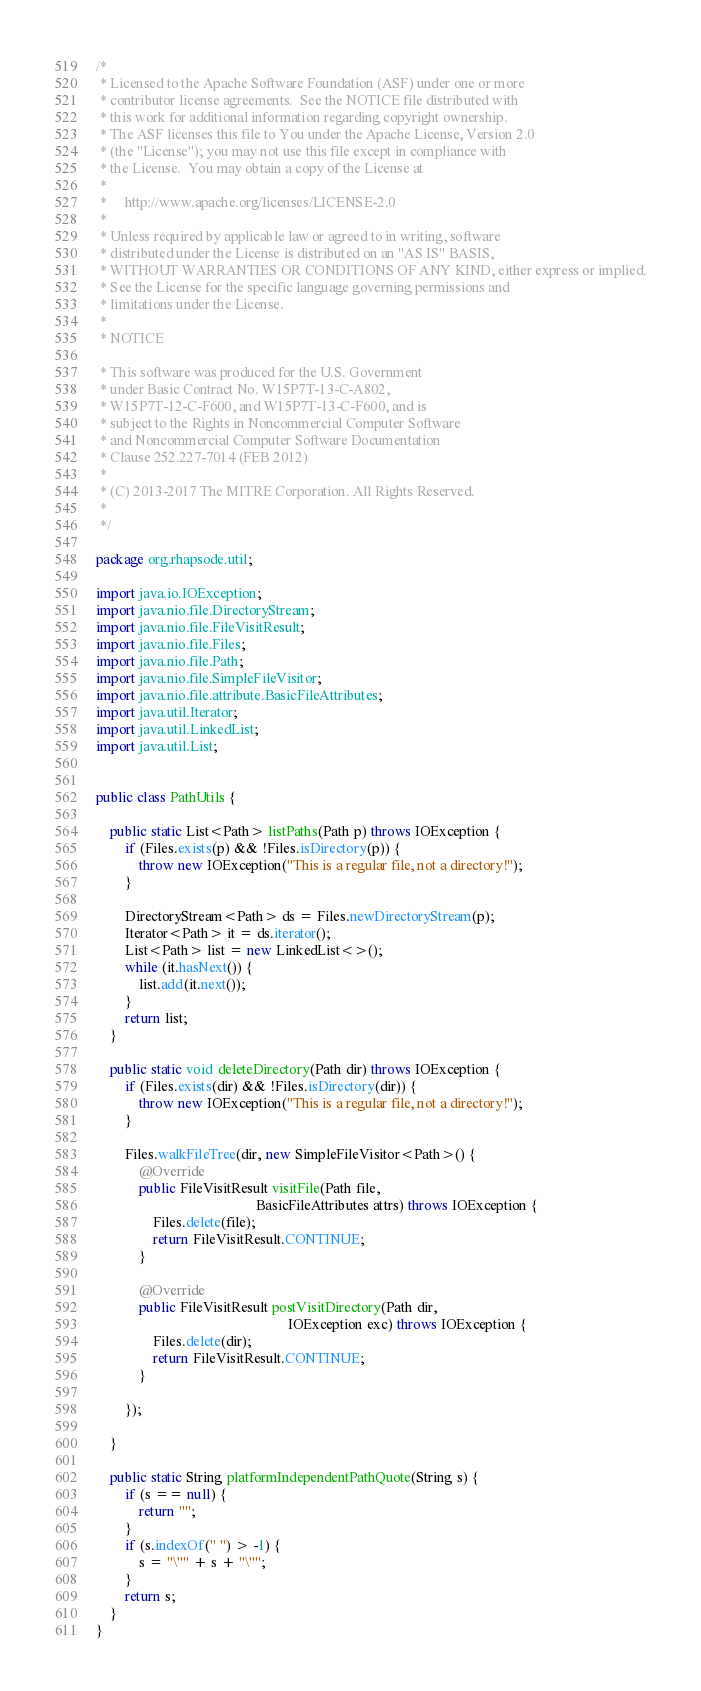<code> <loc_0><loc_0><loc_500><loc_500><_Java_>/*
 * Licensed to the Apache Software Foundation (ASF) under one or more
 * contributor license agreements.  See the NOTICE file distributed with
 * this work for additional information regarding copyright ownership.
 * The ASF licenses this file to You under the Apache License, Version 2.0
 * (the "License"); you may not use this file except in compliance with
 * the License.  You may obtain a copy of the License at
 *
 *     http://www.apache.org/licenses/LICENSE-2.0
 *
 * Unless required by applicable law or agreed to in writing, software
 * distributed under the License is distributed on an "AS IS" BASIS,
 * WITHOUT WARRANTIES OR CONDITIONS OF ANY KIND, either express or implied.
 * See the License for the specific language governing permissions and
 * limitations under the License.
 *
 * NOTICE

 * This software was produced for the U.S. Government
 * under Basic Contract No. W15P7T-13-C-A802,
 * W15P7T-12-C-F600, and W15P7T-13-C-F600, and is
 * subject to the Rights in Noncommercial Computer Software
 * and Noncommercial Computer Software Documentation
 * Clause 252.227-7014 (FEB 2012)
 *
 * (C) 2013-2017 The MITRE Corporation. All Rights Reserved.
 *
 */

package org.rhapsode.util;

import java.io.IOException;
import java.nio.file.DirectoryStream;
import java.nio.file.FileVisitResult;
import java.nio.file.Files;
import java.nio.file.Path;
import java.nio.file.SimpleFileVisitor;
import java.nio.file.attribute.BasicFileAttributes;
import java.util.Iterator;
import java.util.LinkedList;
import java.util.List;


public class PathUtils {

    public static List<Path> listPaths(Path p) throws IOException {
        if (Files.exists(p) && !Files.isDirectory(p)) {
            throw new IOException("This is a regular file, not a directory!");
        }

        DirectoryStream<Path> ds = Files.newDirectoryStream(p);
        Iterator<Path> it = ds.iterator();
        List<Path> list = new LinkedList<>();
        while (it.hasNext()) {
            list.add(it.next());
        }
        return list;
    }

    public static void deleteDirectory(Path dir) throws IOException {
        if (Files.exists(dir) && !Files.isDirectory(dir)) {
            throw new IOException("This is a regular file, not a directory!");
        }

        Files.walkFileTree(dir, new SimpleFileVisitor<Path>() {
            @Override
            public FileVisitResult visitFile(Path file,
                                             BasicFileAttributes attrs) throws IOException {
                Files.delete(file);
                return FileVisitResult.CONTINUE;
            }

            @Override
            public FileVisitResult postVisitDirectory(Path dir,
                                                      IOException exc) throws IOException {
                Files.delete(dir);
                return FileVisitResult.CONTINUE;
            }

        });

    }

    public static String platformIndependentPathQuote(String s) {
        if (s == null) {
            return "";
        }
        if (s.indexOf(" ") > -1) {
            s = "\"" + s + "\"";
        }
        return s;
    }
}
</code> 